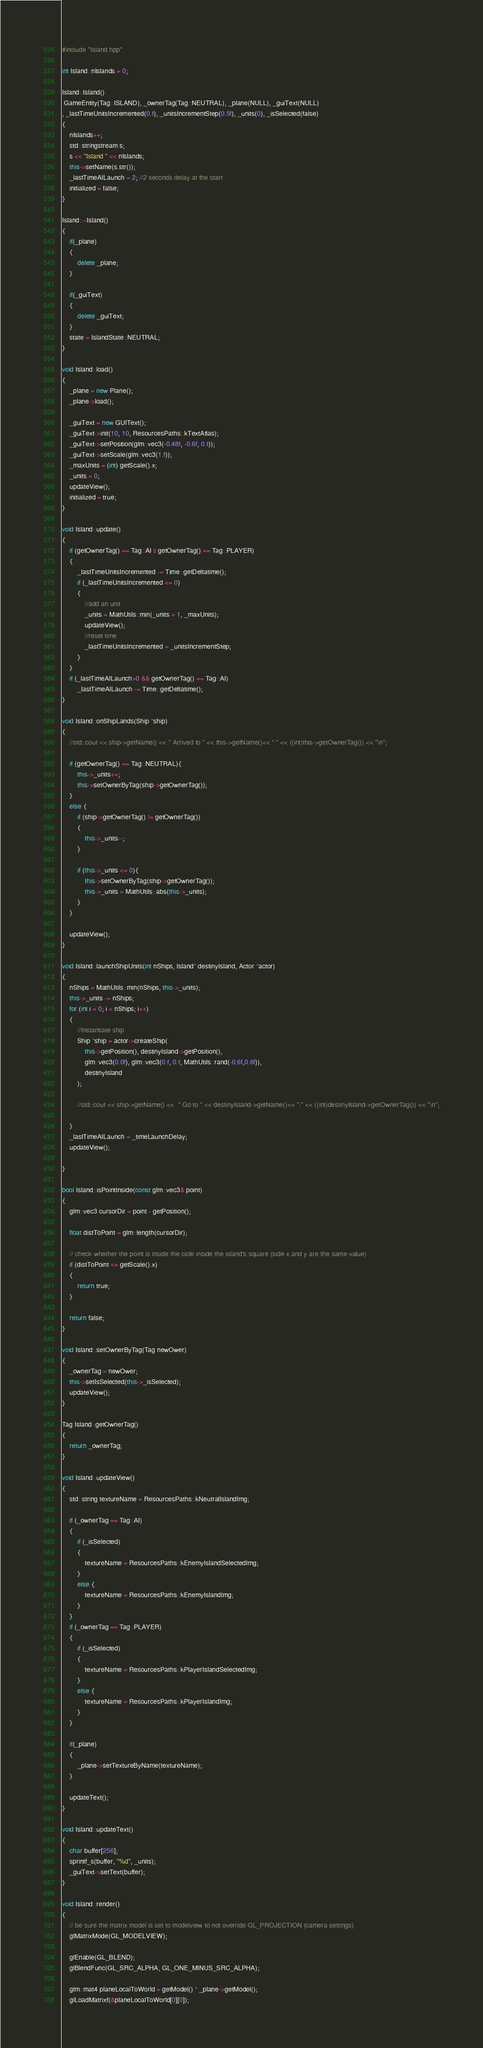Convert code to text. <code><loc_0><loc_0><loc_500><loc_500><_C++_>#include "Island.hpp"

int Island::nIslands = 0;

Island::Island()
:GameEntity(Tag::ISLAND), _ownerTag(Tag::NEUTRAL), _plane(NULL), _guiText(NULL)
, _lastTimeUnitsIncremented(0.f), _unitsIncrementStep(0.5f), _units(0), _isSelected(false)
{
	nIslands++;
	std::stringstream s;
	s << "Island " << nIslands;
	this->setName(s.str());
	_lastTimeAILaunch = 2; //2 seconds delay at the start
	initialized = false;
}

Island::~Island()
{
    if(_plane)
    {
        delete _plane;
    }
    
    if(_guiText)
    {
        delete _guiText;
    }
	state = IslandState::NEUTRAL;
}

void Island::load()
{
	_plane = new Plane();
	_plane->load();
    
	_guiText = new GUIText();
	_guiText->init(10, 10, ResourcesPaths::kTextAtlas);
    _guiText->setPosition(glm::vec3(-0.48f, -0.6f, 0.f));
    _guiText->setScale(glm::vec3(1.f));
	_maxUnits = (int) getScale().x;
	_units = 0;
	updateView();
	initialized = true;
}

void Island::update()
{
	if (getOwnerTag() == Tag::AI || getOwnerTag() == Tag::PLAYER)
	{
		_lastTimeUnitsIncremented -= Time::getDeltatime();
		if (_lastTimeUnitsIncremented <= 0)
		{
			//add an unit
			_units = MathUtils::min(_units + 1, _maxUnits);
			updateView();
			//reset time
			_lastTimeUnitsIncremented = _unitsIncrementStep;
		}
	}
	if (_lastTimeAILaunch>0 && getOwnerTag() == Tag::AI)
		_lastTimeAILaunch -= Time::getDeltatime();
}

void Island::onShipLands(Ship *ship)
{
	//std::cout << ship->getName() << " Arrived to " << this->getName()<< ":" << ((int)this->getOwnerTag()) << "\n";
	
	if (getOwnerTag() == Tag::NEUTRAL){
		this->_units++;
		this->setOwnerByTag(ship->getOwnerTag());
	}
	else {
		if (ship->getOwnerTag() != getOwnerTag())
		{
			this->_units--;
		}

		if (this->_units <= 0){
			this->setOwnerByTag(ship->getOwnerTag());
			this->_units = MathUtils::abs(this->_units);
		}
	}

	updateView();
}

void Island::launchShipUnits(int nShips, Island* destinyIsland, Actor *actor)
{
	nShips = MathUtils::min(nShips, this->_units);
	this->_units -= nShips;
	for (int i = 0; i < nShips; i++)
	{
		//Instantiate ship
		Ship *ship = actor->createShip(
			this->getPosition(), destinyIsland->getPosition(),
			glm::vec3(0.0f), glm::vec3(0.f, 0.f, MathUtils::rand(-0.6f,0.6f)),
			destinyIsland
		);
		
		//std::cout << ship->getName() <<  " Go to " << destinyIsland->getName()<< ":" << ((int)destinyIsland->getOwnerTag()) << "\n";
		
	}
	_lastTimeAILaunch = _timeLaunchDelay;
	updateView();
	
}

bool Island::isPointInside(const glm::vec3& point)
{
	glm::vec3 cursorDir = point - getPosition();
    
	float distToPoint = glm::length(cursorDir);
    
    // check whether the point is inside the cicle inside the island's square (side x and y are the same value)
	if (distToPoint <= getScale().x)
	{
		return true;
	}
    
	return false;
}

void Island::setOwnerByTag(Tag newOwer)
{
	_ownerTag = newOwer;
	this->setIsSelected(this->_isSelected);
    updateView();
}

Tag Island::getOwnerTag()
{
	return _ownerTag;
}

void Island::updateView()
{
	std::string textureName = ResourcesPaths::kNeutralIslandImg;
    
	if (_ownerTag == Tag::AI)
	{
        if (_isSelected)
		{
			textureName = ResourcesPaths::kEnemyIslandSelectedImg;
		}
		else {
			textureName = ResourcesPaths::kEnemyIslandImg;
		}
	}
	if (_ownerTag == Tag::PLAYER)
	{
		if (_isSelected)
		{
			textureName = ResourcesPaths::kPlayerIslandSelectedImg;
		}
		else {
			textureName = ResourcesPaths::kPlayerIslandImg;
		}
	}
    
    if(_plane)
    {
        _plane->setTextureByName(textureName);
    }
    
    updateText();
}

void Island::updateText()
{
	char buffer[256];
	sprintf_s(buffer, "%d", _units);
	_guiText->setText(buffer);
}

void Island::render()
{   
    // be sure the matrix model is set to modelview to not override GL_PROJECTION (camera settings)
	glMatrixMode(GL_MODELVIEW);
    
    glEnable(GL_BLEND);
    glBlendFunc(GL_SRC_ALPHA, GL_ONE_MINUS_SRC_ALPHA);
    
    glm::mat4 planeLocalToWorld = getModel() * _plane->getModel();
	glLoadMatrixf(&planeLocalToWorld[0][0]);</code> 